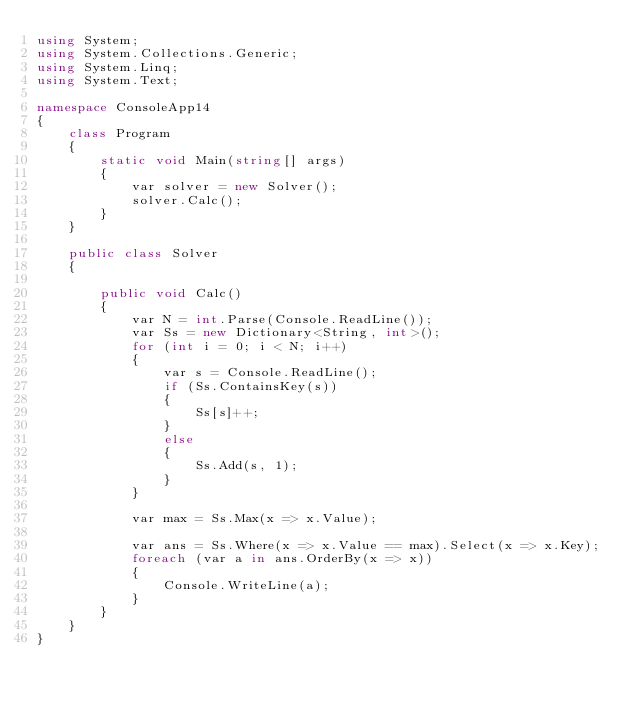Convert code to text. <code><loc_0><loc_0><loc_500><loc_500><_C#_>using System;
using System.Collections.Generic;
using System.Linq;
using System.Text;

namespace ConsoleApp14
{
    class Program
    {
        static void Main(string[] args)
        {
            var solver = new Solver();
            solver.Calc();
        }
    }

    public class Solver
    {

        public void Calc()
        {
            var N = int.Parse(Console.ReadLine());
            var Ss = new Dictionary<String, int>();
            for (int i = 0; i < N; i++)
            {
                var s = Console.ReadLine();
                if (Ss.ContainsKey(s))
                {
                    Ss[s]++;
                }
                else
                {
                    Ss.Add(s, 1);
                }
            }

            var max = Ss.Max(x => x.Value);

            var ans = Ss.Where(x => x.Value == max).Select(x => x.Key);
            foreach (var a in ans.OrderBy(x => x))
            {
                Console.WriteLine(a);
            }
        }
    }
}</code> 